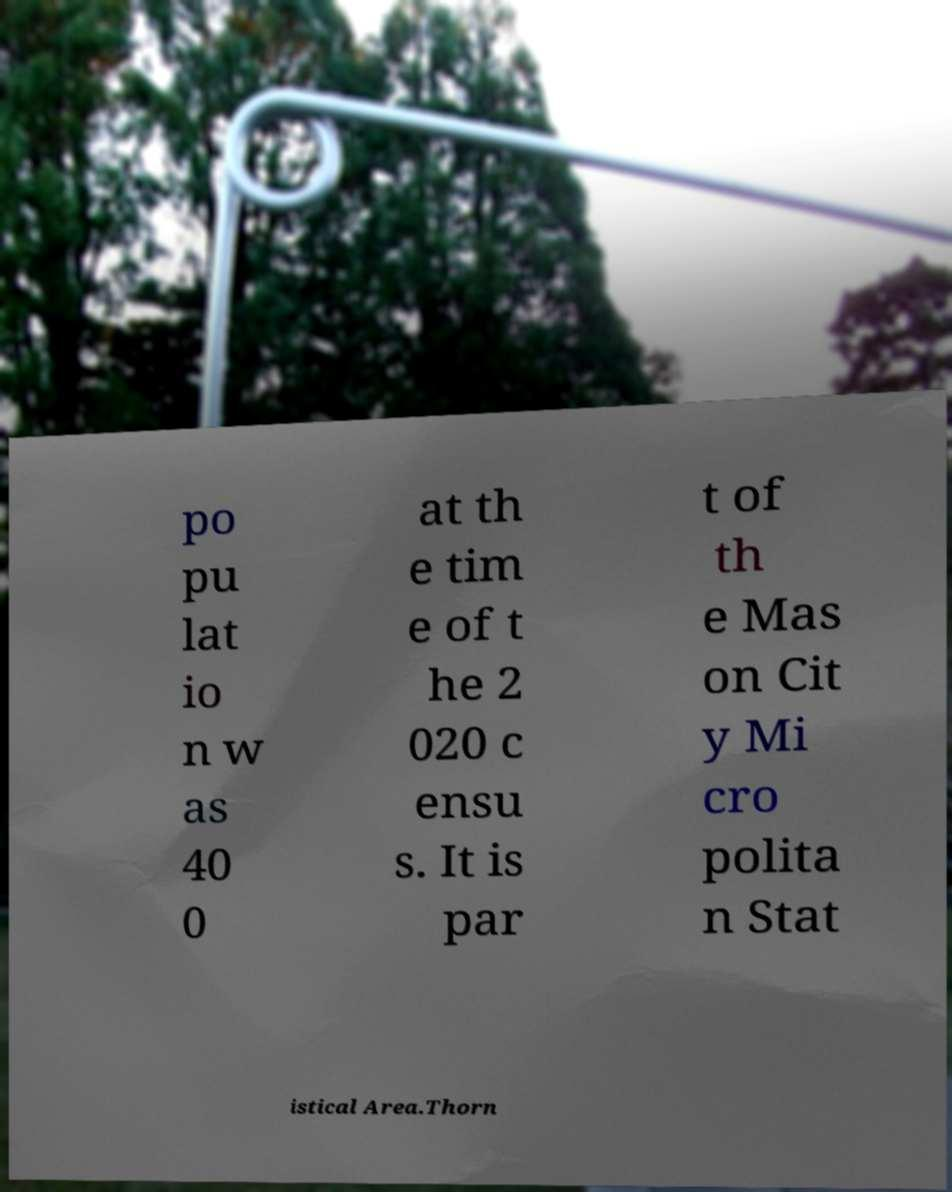Can you read and provide the text displayed in the image?This photo seems to have some interesting text. Can you extract and type it out for me? po pu lat io n w as 40 0 at th e tim e of t he 2 020 c ensu s. It is par t of th e Mas on Cit y Mi cro polita n Stat istical Area.Thorn 